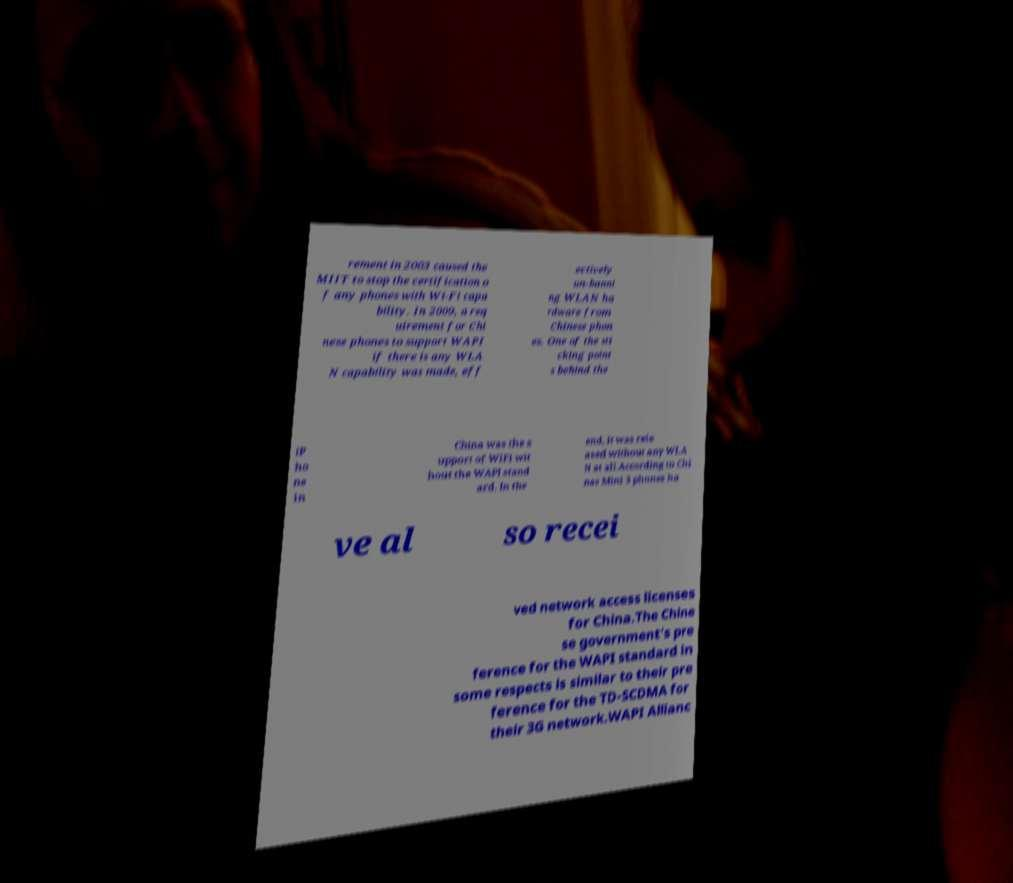I need the written content from this picture converted into text. Can you do that? rement in 2003 caused the MIIT to stop the certification o f any phones with Wi-Fi capa bility. In 2009, a req uirement for Chi nese phones to support WAPI if there is any WLA N capability was made, eff ectively un-banni ng WLAN ha rdware from Chinese phon es. One of the sti cking point s behind the iP ho ne in China was the s upport of WiFi wit hout the WAPI stand ard. In the end, it was rele ased without any WLA N at all.According to Chi nas Mini 3 phones ha ve al so recei ved network access licenses for China.The Chine se government's pre ference for the WAPI standard in some respects is similar to their pre ference for the TD-SCDMA for their 3G network.WAPI Allianc 